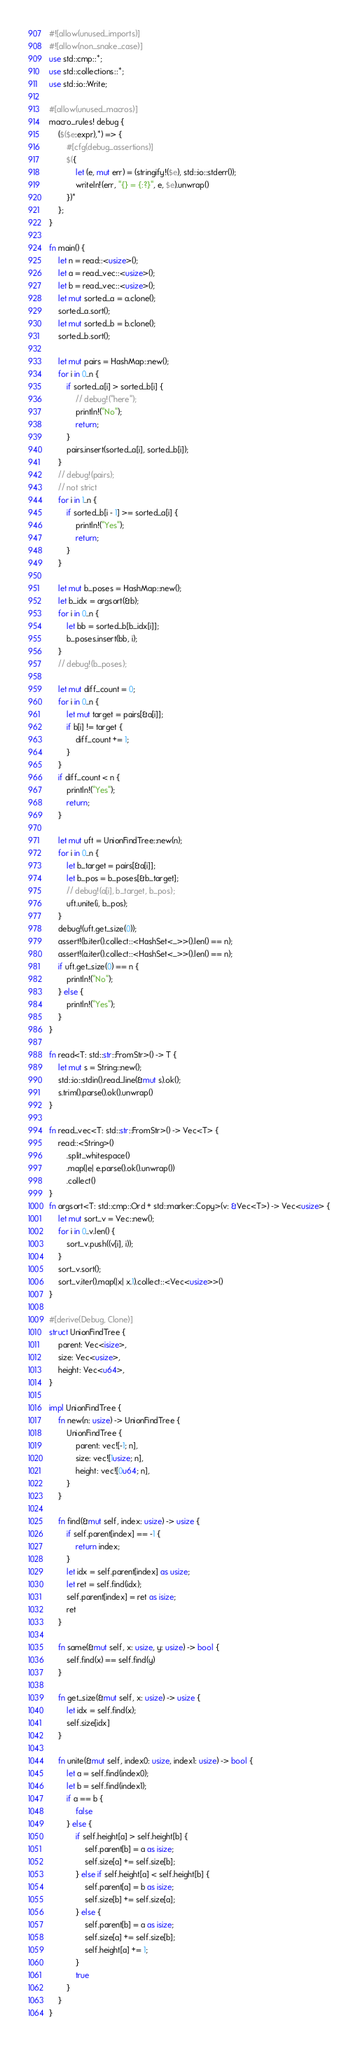<code> <loc_0><loc_0><loc_500><loc_500><_Rust_>#![allow(unused_imports)]
#![allow(non_snake_case)]
use std::cmp::*;
use std::collections::*;
use std::io::Write;

#[allow(unused_macros)]
macro_rules! debug {
    ($($e:expr),*) => {
        #[cfg(debug_assertions)]
        $({
            let (e, mut err) = (stringify!($e), std::io::stderr());
            writeln!(err, "{} = {:?}", e, $e).unwrap()
        })*
    };
}

fn main() {
    let n = read::<usize>();
    let a = read_vec::<usize>();
    let b = read_vec::<usize>();
    let mut sorted_a = a.clone();
    sorted_a.sort();
    let mut sorted_b = b.clone();
    sorted_b.sort();

    let mut pairs = HashMap::new();
    for i in 0..n {
        if sorted_a[i] > sorted_b[i] {
            // debug!("here");
            println!("No");
            return;
        }
        pairs.insert(sorted_a[i], sorted_b[i]);
    }
    // debug!(pairs);
    // not strict
    for i in 1..n {
        if sorted_b[i - 1] >= sorted_a[i] {
            println!("Yes");
            return;
        }
    }

    let mut b_poses = HashMap::new();
    let b_idx = argsort(&b);
    for i in 0..n {
        let bb = sorted_b[b_idx[i]];
        b_poses.insert(bb, i);
    }
    // debug!(b_poses);

    let mut diff_count = 0;
    for i in 0..n {
        let mut target = pairs[&a[i]];
        if b[i] != target {
            diff_count += 1;
        }
    }
    if diff_count < n {
        println!("Yes");
        return;
    }

    let mut uft = UnionFindTree::new(n);
    for i in 0..n {
        let b_target = pairs[&a[i]];
        let b_pos = b_poses[&b_target];
        // debug!(a[i], b_target, b_pos);
        uft.unite(i, b_pos);
    }
    debug!(uft.get_size(0));
    assert!(b.iter().collect::<HashSet<_>>().len() == n);
    assert!(a.iter().collect::<HashSet<_>>().len() == n);
    if uft.get_size(0) == n {
        println!("No");
    } else {
        println!("Yes");
    }
}

fn read<T: std::str::FromStr>() -> T {
    let mut s = String::new();
    std::io::stdin().read_line(&mut s).ok();
    s.trim().parse().ok().unwrap()
}

fn read_vec<T: std::str::FromStr>() -> Vec<T> {
    read::<String>()
        .split_whitespace()
        .map(|e| e.parse().ok().unwrap())
        .collect()
}
fn argsort<T: std::cmp::Ord + std::marker::Copy>(v: &Vec<T>) -> Vec<usize> {
    let mut sort_v = Vec::new();
    for i in 0..v.len() {
        sort_v.push((v[i], i));
    }
    sort_v.sort();
    sort_v.iter().map(|x| x.1).collect::<Vec<usize>>()
}

#[derive(Debug, Clone)]
struct UnionFindTree {
    parent: Vec<isize>,
    size: Vec<usize>,
    height: Vec<u64>,
}

impl UnionFindTree {
    fn new(n: usize) -> UnionFindTree {
        UnionFindTree {
            parent: vec![-1; n],
            size: vec![1usize; n],
            height: vec![0u64; n],
        }
    }

    fn find(&mut self, index: usize) -> usize {
        if self.parent[index] == -1 {
            return index;
        }
        let idx = self.parent[index] as usize;
        let ret = self.find(idx);
        self.parent[index] = ret as isize;
        ret
    }

    fn same(&mut self, x: usize, y: usize) -> bool {
        self.find(x) == self.find(y)
    }

    fn get_size(&mut self, x: usize) -> usize {
        let idx = self.find(x);
        self.size[idx]
    }

    fn unite(&mut self, index0: usize, index1: usize) -> bool {
        let a = self.find(index0);
        let b = self.find(index1);
        if a == b {
            false
        } else {
            if self.height[a] > self.height[b] {
                self.parent[b] = a as isize;
                self.size[a] += self.size[b];
            } else if self.height[a] < self.height[b] {
                self.parent[a] = b as isize;
                self.size[b] += self.size[a];
            } else {
                self.parent[b] = a as isize;
                self.size[a] += self.size[b];
                self.height[a] += 1;
            }
            true
        }
    }
}
</code> 